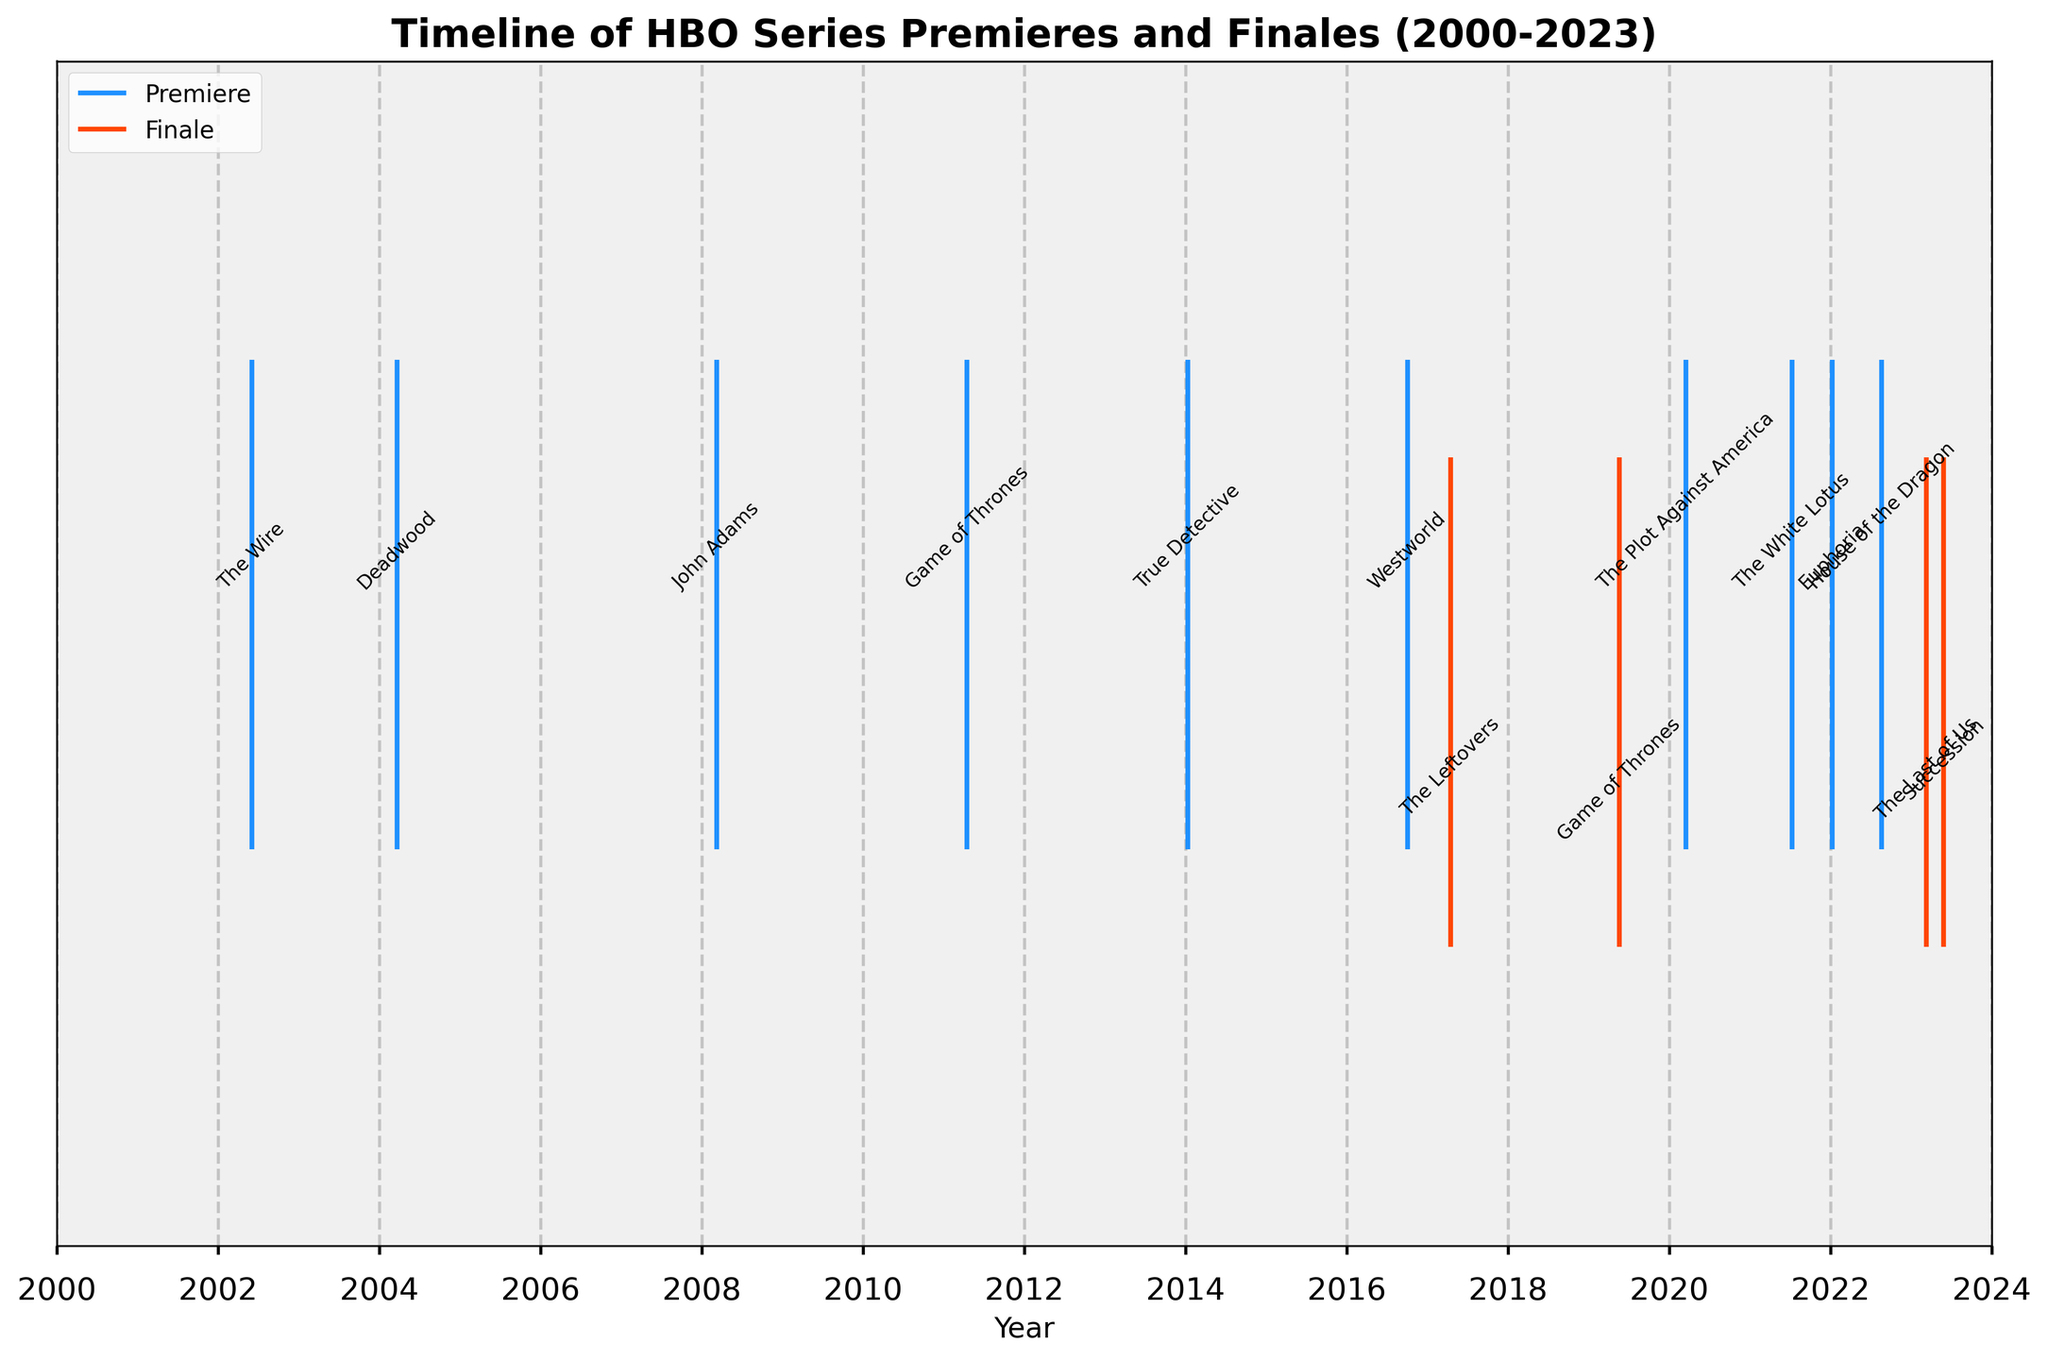When did 'The Wire' premiere? The event plot marks 'The Wire' premiere with a label right above the date. By looking to the left-most premiere event labeled 'The Wire', we see the premiere date.
Answer: June 2, 2002 How many HBO series premieres are shown in the figure? The event plot uses blue lines to represent series premieres. By counting the blue lines within the figure, we can determine the number of premieres.
Answer: 8 Which series finale happened in May 2023? By looking at the red line with a label in May 2023, the corresponding series finale event is labeled 'Succession'.
Answer: Succession What happened in April 2017 according to the figure? The figure labels events with dates. Looking for events around April 2017, we see a red line marked as the finale of 'The Leftovers'.
Answer: The Leftovers finale How long did 'Game of Thrones' run? Find the premiere and finale dates of 'Game of Thrones' on the plot. 'Game of Thrones' premiered in April 2011 and had its finale in May 2019. Subtract the premiere year from the finale year.
Answer: 8 years Which series had the most recent premiere based on the figure? The event plot will have the most recent premiere marked by the right-most blue line. Check the label for this line to find the series name 'House of the Dragon'.
Answer: House of the Dragon What are the premiere and finale date ranges shown on the plot? The x-axis of the plot indicates dates from around 2000 to 2023. The earliest premiere is 'The Wire' in June 2002, and the latest finale is 'Succession' in May 2023.
Answer: 2002 to 2023 Which series finale occurred closest to 'Game of Thrones' finale? Look for red lines nearest to the 'Game of Thrones' finale date in May 2019. The closest finale is 'The Last of Us' in March 2023.
Answer: The Last of Us Do more series premiere or finish between 2020 and 2023? Count the number of blue and red lines within the date range 2020-2023. There are 4 premieres ('The Plot Against America', 'The White Lotus', 'Euphoria', and 'House of the Dragon') and 2 finales ('The Last of Us' and 'Succession').
Answer: More premieres How many years after 'The Wire' premiere did 'Game of Thrones' premiere? 'The Wire' premiered in June 2002 and 'Game of Thrones' premiered in April 2011. Subtract the premiere years: 2011 - 2002.
Answer: 9 years 